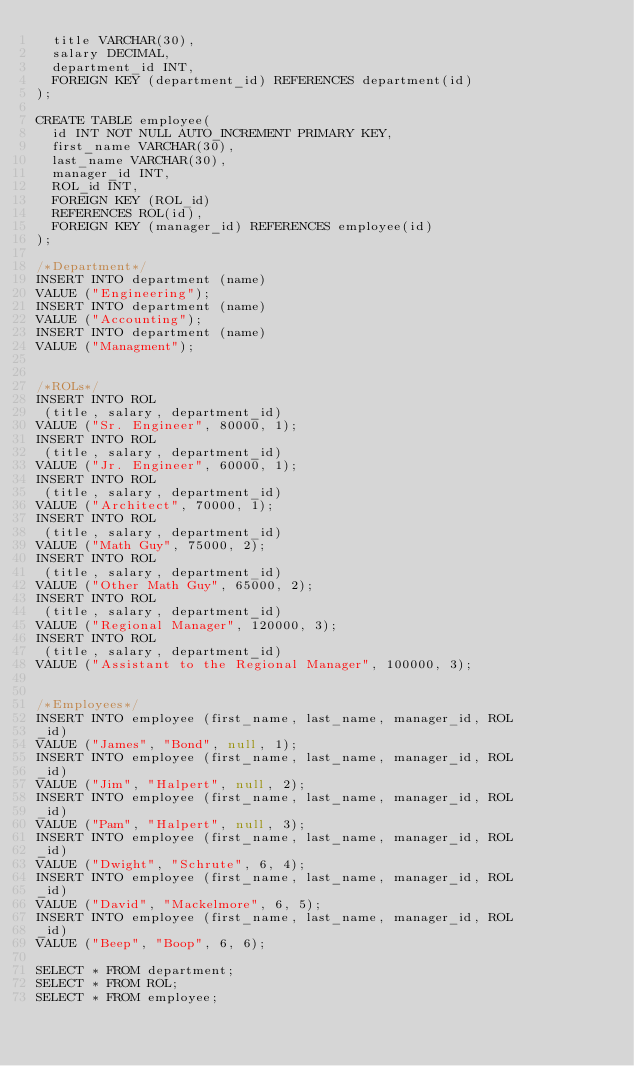Convert code to text. <code><loc_0><loc_0><loc_500><loc_500><_SQL_>  title VARCHAR(30),
  salary DECIMAL,
  department_id INT,
  FOREIGN KEY (department_id) REFERENCES department(id)
);

CREATE TABLE employee(
  id INT NOT NULL AUTO_INCREMENT PRIMARY KEY,
  first_name VARCHAR(30),
  last_name VARCHAR(30),
  manager_id INT,
  ROL_id INT,
  FOREIGN KEY (ROL_id) 
  REFERENCES ROL(id),
  FOREIGN KEY (manager_id) REFERENCES employee(id)
);

/*Department*/
INSERT INTO department (name)
VALUE ("Engineering");
INSERT INTO department (name)
VALUE ("Accounting");
INSERT INTO department (name)
VALUE ("Managment");


/*ROLs*/
INSERT INTO ROL
 (title, salary, department_id) 
VALUE ("Sr. Engineer", 80000, 1);
INSERT INTO ROL
 (title, salary, department_id) 
VALUE ("Jr. Engineer", 60000, 1);
INSERT INTO ROL
 (title, salary, department_id) 
VALUE ("Architect", 70000, 1);
INSERT INTO ROL
 (title, salary, department_id) 
VALUE ("Math Guy", 75000, 2);
INSERT INTO ROL
 (title, salary, department_id) 
VALUE ("Other Math Guy", 65000, 2);
INSERT INTO ROL
 (title, salary, department_id) 
VALUE ("Regional Manager", 120000, 3);
INSERT INTO ROL
 (title, salary, department_id) 
VALUE ("Assistant to the Regional Manager", 100000, 3);


/*Employees*/
INSERT INTO employee (first_name, last_name, manager_id, ROL
_id)
VALUE ("James", "Bond", null, 1);
INSERT INTO employee (first_name, last_name, manager_id, ROL
_id)
VALUE ("Jim", "Halpert", null, 2);
INSERT INTO employee (first_name, last_name, manager_id, ROL
_id)
VALUE ("Pam", "Halpert", null, 3);
INSERT INTO employee (first_name, last_name, manager_id, ROL
_id)
VALUE ("Dwight", "Schrute", 6, 4);
INSERT INTO employee (first_name, last_name, manager_id, ROL
_id)
VALUE ("David", "Mackelmore", 6, 5);
INSERT INTO employee (first_name, last_name, manager_id, ROL
_id)
VALUE ("Beep", "Boop", 6, 6);

SELECT * FROM department;
SELECT * FROM ROL;
SELECT * FROM employee;


</code> 